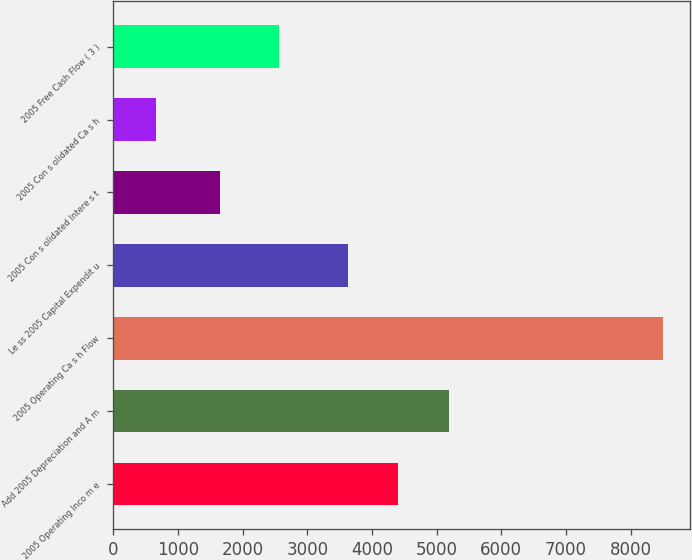<chart> <loc_0><loc_0><loc_500><loc_500><bar_chart><fcel>2005 Operating Inco m e<fcel>Add 2005 Depreciation and A m<fcel>2005 Operating Ca s h Flow<fcel>Le ss 2005 Capital Expendit u<fcel>2005 Con s olidated Intere s t<fcel>2005 Con s olidated Ca s h<fcel>2005 Free Cash Flow ( 3 )<nl><fcel>4405<fcel>5189<fcel>8493<fcel>3621<fcel>1653<fcel>653<fcel>2566<nl></chart> 